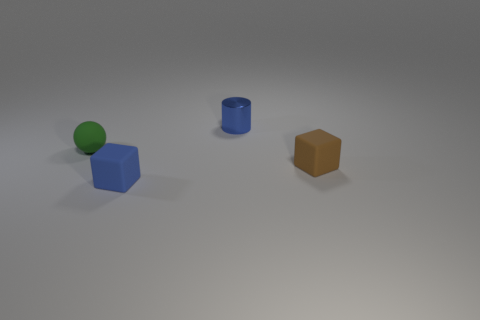How many blue blocks have the same material as the small green object?
Offer a very short reply. 1. What color is the small ball that is made of the same material as the brown block?
Ensure brevity in your answer.  Green. There is a tiny matte thing that is behind the small brown rubber block; does it have the same color as the small cylinder?
Provide a short and direct response. No. There is a small blue object behind the tiny brown rubber object; what is it made of?
Ensure brevity in your answer.  Metal. Are there the same number of small green matte balls that are behind the small metallic cylinder and blue metallic objects?
Offer a very short reply. No. What number of rubber blocks have the same color as the small shiny cylinder?
Ensure brevity in your answer.  1. There is another thing that is the same shape as the small brown matte object; what is its color?
Your answer should be compact. Blue. Do the blue matte object and the shiny cylinder have the same size?
Give a very brief answer. Yes. Is the number of blue cubes left of the matte sphere the same as the number of matte cubes behind the blue block?
Offer a terse response. No. Are any blue cubes visible?
Provide a short and direct response. Yes. 